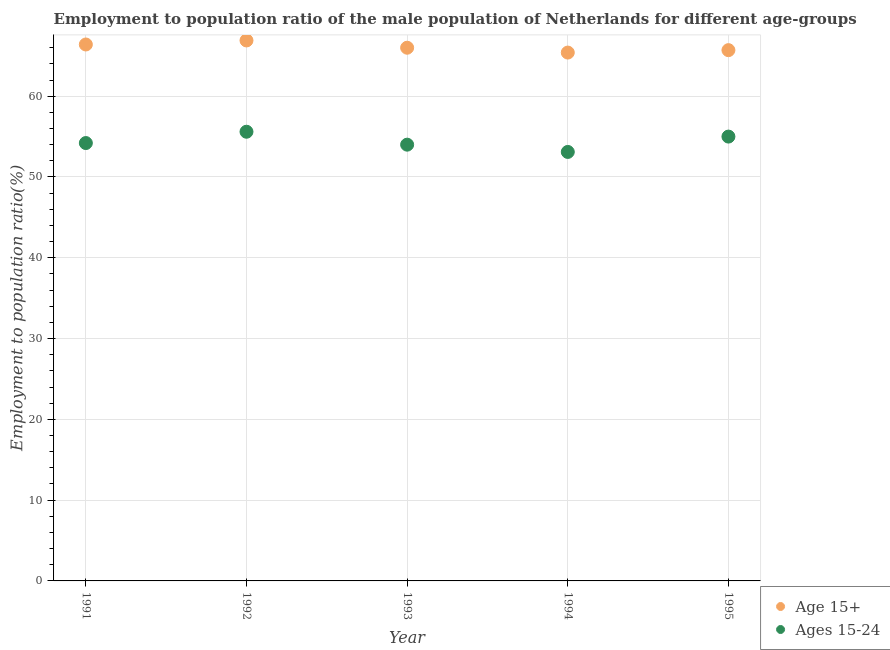Is the number of dotlines equal to the number of legend labels?
Provide a short and direct response. Yes. Across all years, what is the maximum employment to population ratio(age 15+)?
Ensure brevity in your answer.  66.9. Across all years, what is the minimum employment to population ratio(age 15+)?
Your response must be concise. 65.4. In which year was the employment to population ratio(age 15+) minimum?
Your answer should be compact. 1994. What is the total employment to population ratio(age 15+) in the graph?
Give a very brief answer. 330.4. What is the difference between the employment to population ratio(age 15+) in 1994 and that in 1995?
Your answer should be compact. -0.3. What is the difference between the employment to population ratio(age 15-24) in 1994 and the employment to population ratio(age 15+) in 1991?
Your response must be concise. -13.3. What is the average employment to population ratio(age 15-24) per year?
Ensure brevity in your answer.  54.38. In the year 1993, what is the difference between the employment to population ratio(age 15-24) and employment to population ratio(age 15+)?
Ensure brevity in your answer.  -12. What is the ratio of the employment to population ratio(age 15+) in 1992 to that in 1994?
Your answer should be very brief. 1.02. Is the employment to population ratio(age 15+) in 1994 less than that in 1995?
Your response must be concise. Yes. Is the difference between the employment to population ratio(age 15-24) in 1991 and 1995 greater than the difference between the employment to population ratio(age 15+) in 1991 and 1995?
Offer a very short reply. No. What is the difference between the highest and the second highest employment to population ratio(age 15+)?
Offer a terse response. 0.5. What is the difference between the highest and the lowest employment to population ratio(age 15-24)?
Your response must be concise. 2.5. Does the employment to population ratio(age 15-24) monotonically increase over the years?
Your response must be concise. No. Is the employment to population ratio(age 15-24) strictly greater than the employment to population ratio(age 15+) over the years?
Ensure brevity in your answer.  No. How many dotlines are there?
Provide a short and direct response. 2. How many years are there in the graph?
Offer a terse response. 5. Does the graph contain grids?
Give a very brief answer. Yes. Where does the legend appear in the graph?
Your answer should be very brief. Bottom right. How are the legend labels stacked?
Your response must be concise. Vertical. What is the title of the graph?
Your response must be concise. Employment to population ratio of the male population of Netherlands for different age-groups. Does "Manufacturing industries and construction" appear as one of the legend labels in the graph?
Your answer should be compact. No. What is the Employment to population ratio(%) of Age 15+ in 1991?
Provide a succinct answer. 66.4. What is the Employment to population ratio(%) in Ages 15-24 in 1991?
Offer a terse response. 54.2. What is the Employment to population ratio(%) in Age 15+ in 1992?
Your answer should be compact. 66.9. What is the Employment to population ratio(%) of Ages 15-24 in 1992?
Provide a succinct answer. 55.6. What is the Employment to population ratio(%) of Age 15+ in 1993?
Make the answer very short. 66. What is the Employment to population ratio(%) of Age 15+ in 1994?
Your answer should be very brief. 65.4. What is the Employment to population ratio(%) in Ages 15-24 in 1994?
Ensure brevity in your answer.  53.1. What is the Employment to population ratio(%) in Age 15+ in 1995?
Keep it short and to the point. 65.7. Across all years, what is the maximum Employment to population ratio(%) of Age 15+?
Give a very brief answer. 66.9. Across all years, what is the maximum Employment to population ratio(%) in Ages 15-24?
Your answer should be compact. 55.6. Across all years, what is the minimum Employment to population ratio(%) in Age 15+?
Give a very brief answer. 65.4. Across all years, what is the minimum Employment to population ratio(%) of Ages 15-24?
Give a very brief answer. 53.1. What is the total Employment to population ratio(%) in Age 15+ in the graph?
Ensure brevity in your answer.  330.4. What is the total Employment to population ratio(%) in Ages 15-24 in the graph?
Give a very brief answer. 271.9. What is the difference between the Employment to population ratio(%) of Ages 15-24 in 1991 and that in 1992?
Your answer should be compact. -1.4. What is the difference between the Employment to population ratio(%) of Age 15+ in 1991 and that in 1995?
Provide a short and direct response. 0.7. What is the difference between the Employment to population ratio(%) in Ages 15-24 in 1991 and that in 1995?
Your answer should be compact. -0.8. What is the difference between the Employment to population ratio(%) of Age 15+ in 1992 and that in 1994?
Offer a very short reply. 1.5. What is the difference between the Employment to population ratio(%) in Age 15+ in 1993 and that in 1994?
Keep it short and to the point. 0.6. What is the difference between the Employment to population ratio(%) of Ages 15-24 in 1993 and that in 1994?
Offer a terse response. 0.9. What is the difference between the Employment to population ratio(%) in Age 15+ in 1993 and that in 1995?
Your response must be concise. 0.3. What is the difference between the Employment to population ratio(%) in Ages 15-24 in 1993 and that in 1995?
Keep it short and to the point. -1. What is the difference between the Employment to population ratio(%) of Ages 15-24 in 1994 and that in 1995?
Your answer should be compact. -1.9. What is the difference between the Employment to population ratio(%) in Age 15+ in 1991 and the Employment to population ratio(%) in Ages 15-24 in 1993?
Make the answer very short. 12.4. What is the difference between the Employment to population ratio(%) in Age 15+ in 1991 and the Employment to population ratio(%) in Ages 15-24 in 1994?
Keep it short and to the point. 13.3. What is the difference between the Employment to population ratio(%) of Age 15+ in 1992 and the Employment to population ratio(%) of Ages 15-24 in 1993?
Provide a succinct answer. 12.9. What is the difference between the Employment to population ratio(%) in Age 15+ in 1992 and the Employment to population ratio(%) in Ages 15-24 in 1995?
Offer a very short reply. 11.9. What is the difference between the Employment to population ratio(%) of Age 15+ in 1993 and the Employment to population ratio(%) of Ages 15-24 in 1995?
Keep it short and to the point. 11. What is the average Employment to population ratio(%) in Age 15+ per year?
Offer a terse response. 66.08. What is the average Employment to population ratio(%) in Ages 15-24 per year?
Offer a terse response. 54.38. In the year 1992, what is the difference between the Employment to population ratio(%) in Age 15+ and Employment to population ratio(%) in Ages 15-24?
Make the answer very short. 11.3. In the year 1993, what is the difference between the Employment to population ratio(%) in Age 15+ and Employment to population ratio(%) in Ages 15-24?
Give a very brief answer. 12. In the year 1994, what is the difference between the Employment to population ratio(%) of Age 15+ and Employment to population ratio(%) of Ages 15-24?
Give a very brief answer. 12.3. In the year 1995, what is the difference between the Employment to population ratio(%) of Age 15+ and Employment to population ratio(%) of Ages 15-24?
Your answer should be very brief. 10.7. What is the ratio of the Employment to population ratio(%) of Ages 15-24 in 1991 to that in 1992?
Provide a short and direct response. 0.97. What is the ratio of the Employment to population ratio(%) of Age 15+ in 1991 to that in 1994?
Provide a succinct answer. 1.02. What is the ratio of the Employment to population ratio(%) of Ages 15-24 in 1991 to that in 1994?
Keep it short and to the point. 1.02. What is the ratio of the Employment to population ratio(%) in Age 15+ in 1991 to that in 1995?
Make the answer very short. 1.01. What is the ratio of the Employment to population ratio(%) of Ages 15-24 in 1991 to that in 1995?
Offer a terse response. 0.99. What is the ratio of the Employment to population ratio(%) of Age 15+ in 1992 to that in 1993?
Make the answer very short. 1.01. What is the ratio of the Employment to population ratio(%) of Ages 15-24 in 1992 to that in 1993?
Make the answer very short. 1.03. What is the ratio of the Employment to population ratio(%) in Age 15+ in 1992 to that in 1994?
Give a very brief answer. 1.02. What is the ratio of the Employment to population ratio(%) of Ages 15-24 in 1992 to that in 1994?
Keep it short and to the point. 1.05. What is the ratio of the Employment to population ratio(%) of Age 15+ in 1992 to that in 1995?
Provide a short and direct response. 1.02. What is the ratio of the Employment to population ratio(%) of Ages 15-24 in 1992 to that in 1995?
Give a very brief answer. 1.01. What is the ratio of the Employment to population ratio(%) in Age 15+ in 1993 to that in 1994?
Make the answer very short. 1.01. What is the ratio of the Employment to population ratio(%) in Ages 15-24 in 1993 to that in 1994?
Offer a terse response. 1.02. What is the ratio of the Employment to population ratio(%) in Ages 15-24 in 1993 to that in 1995?
Your answer should be very brief. 0.98. What is the ratio of the Employment to population ratio(%) in Ages 15-24 in 1994 to that in 1995?
Offer a very short reply. 0.97. What is the difference between the highest and the lowest Employment to population ratio(%) of Age 15+?
Give a very brief answer. 1.5. What is the difference between the highest and the lowest Employment to population ratio(%) of Ages 15-24?
Provide a succinct answer. 2.5. 